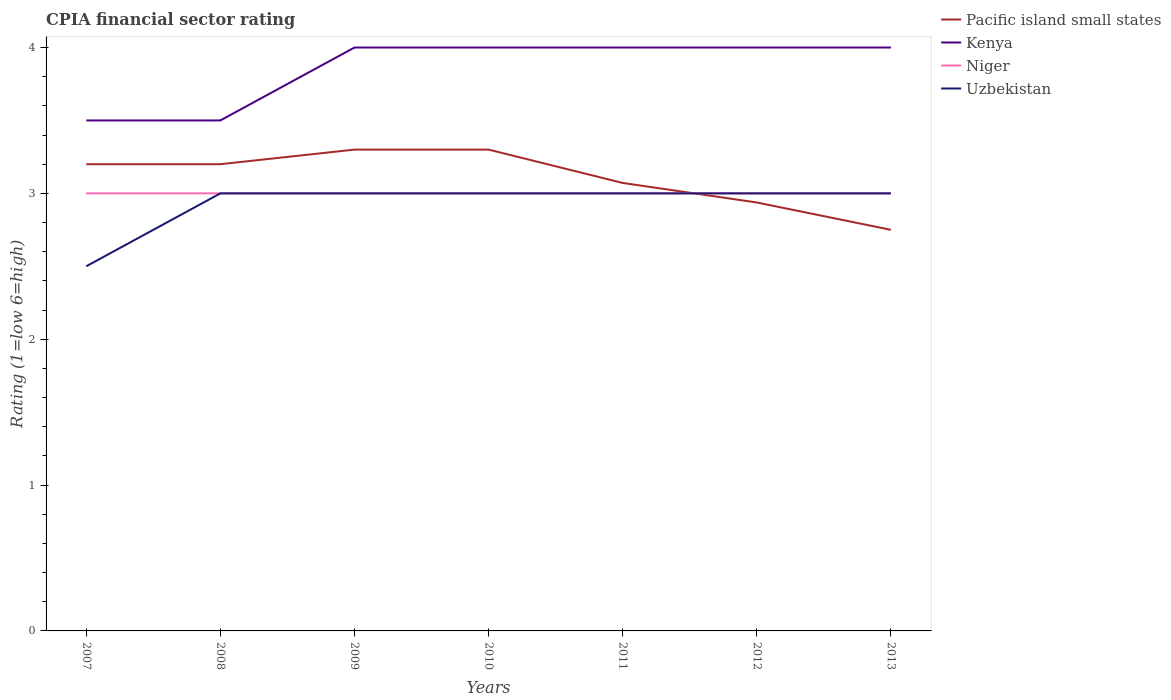How many different coloured lines are there?
Offer a very short reply. 4. Does the line corresponding to Pacific island small states intersect with the line corresponding to Uzbekistan?
Provide a short and direct response. Yes. Across all years, what is the maximum CPIA rating in Niger?
Make the answer very short. 3. What is the total CPIA rating in Pacific island small states in the graph?
Offer a terse response. 0.36. What is the difference between the highest and the lowest CPIA rating in Uzbekistan?
Provide a succinct answer. 6. Does the graph contain grids?
Your answer should be very brief. No. What is the title of the graph?
Keep it short and to the point. CPIA financial sector rating. Does "Argentina" appear as one of the legend labels in the graph?
Your answer should be very brief. No. What is the label or title of the Y-axis?
Your response must be concise. Rating (1=low 6=high). What is the Rating (1=low 6=high) of Kenya in 2007?
Your response must be concise. 3.5. What is the Rating (1=low 6=high) in Uzbekistan in 2007?
Provide a short and direct response. 2.5. What is the Rating (1=low 6=high) in Pacific island small states in 2008?
Ensure brevity in your answer.  3.2. What is the Rating (1=low 6=high) in Uzbekistan in 2008?
Offer a terse response. 3. What is the Rating (1=low 6=high) in Niger in 2009?
Give a very brief answer. 3. What is the Rating (1=low 6=high) in Uzbekistan in 2009?
Give a very brief answer. 3. What is the Rating (1=low 6=high) of Pacific island small states in 2010?
Your answer should be very brief. 3.3. What is the Rating (1=low 6=high) in Niger in 2010?
Provide a short and direct response. 3. What is the Rating (1=low 6=high) in Uzbekistan in 2010?
Your answer should be very brief. 3. What is the Rating (1=low 6=high) in Pacific island small states in 2011?
Offer a terse response. 3.07. What is the Rating (1=low 6=high) in Niger in 2011?
Make the answer very short. 3. What is the Rating (1=low 6=high) in Pacific island small states in 2012?
Provide a short and direct response. 2.94. What is the Rating (1=low 6=high) in Kenya in 2012?
Make the answer very short. 4. What is the Rating (1=low 6=high) of Niger in 2012?
Your response must be concise. 3. What is the Rating (1=low 6=high) of Uzbekistan in 2012?
Make the answer very short. 3. What is the Rating (1=low 6=high) in Pacific island small states in 2013?
Offer a very short reply. 2.75. What is the Rating (1=low 6=high) in Niger in 2013?
Your response must be concise. 3. Across all years, what is the maximum Rating (1=low 6=high) of Pacific island small states?
Your answer should be compact. 3.3. Across all years, what is the maximum Rating (1=low 6=high) in Kenya?
Offer a very short reply. 4. Across all years, what is the maximum Rating (1=low 6=high) in Niger?
Your answer should be very brief. 3. Across all years, what is the minimum Rating (1=low 6=high) of Pacific island small states?
Give a very brief answer. 2.75. What is the total Rating (1=low 6=high) of Pacific island small states in the graph?
Give a very brief answer. 21.76. What is the difference between the Rating (1=low 6=high) of Uzbekistan in 2007 and that in 2008?
Offer a terse response. -0.5. What is the difference between the Rating (1=low 6=high) in Pacific island small states in 2007 and that in 2009?
Your response must be concise. -0.1. What is the difference between the Rating (1=low 6=high) in Uzbekistan in 2007 and that in 2009?
Keep it short and to the point. -0.5. What is the difference between the Rating (1=low 6=high) of Kenya in 2007 and that in 2010?
Offer a terse response. -0.5. What is the difference between the Rating (1=low 6=high) of Uzbekistan in 2007 and that in 2010?
Your answer should be compact. -0.5. What is the difference between the Rating (1=low 6=high) of Pacific island small states in 2007 and that in 2011?
Make the answer very short. 0.13. What is the difference between the Rating (1=low 6=high) in Pacific island small states in 2007 and that in 2012?
Give a very brief answer. 0.26. What is the difference between the Rating (1=low 6=high) in Niger in 2007 and that in 2012?
Your answer should be very brief. 0. What is the difference between the Rating (1=low 6=high) in Uzbekistan in 2007 and that in 2012?
Make the answer very short. -0.5. What is the difference between the Rating (1=low 6=high) of Pacific island small states in 2007 and that in 2013?
Provide a short and direct response. 0.45. What is the difference between the Rating (1=low 6=high) in Niger in 2007 and that in 2013?
Your answer should be very brief. 0. What is the difference between the Rating (1=low 6=high) of Uzbekistan in 2007 and that in 2013?
Provide a succinct answer. -0.5. What is the difference between the Rating (1=low 6=high) of Pacific island small states in 2008 and that in 2009?
Your response must be concise. -0.1. What is the difference between the Rating (1=low 6=high) in Kenya in 2008 and that in 2009?
Ensure brevity in your answer.  -0.5. What is the difference between the Rating (1=low 6=high) in Pacific island small states in 2008 and that in 2010?
Provide a short and direct response. -0.1. What is the difference between the Rating (1=low 6=high) of Kenya in 2008 and that in 2010?
Make the answer very short. -0.5. What is the difference between the Rating (1=low 6=high) of Niger in 2008 and that in 2010?
Provide a succinct answer. 0. What is the difference between the Rating (1=low 6=high) in Uzbekistan in 2008 and that in 2010?
Your answer should be compact. 0. What is the difference between the Rating (1=low 6=high) of Pacific island small states in 2008 and that in 2011?
Give a very brief answer. 0.13. What is the difference between the Rating (1=low 6=high) in Kenya in 2008 and that in 2011?
Provide a succinct answer. -0.5. What is the difference between the Rating (1=low 6=high) in Uzbekistan in 2008 and that in 2011?
Your answer should be very brief. 0. What is the difference between the Rating (1=low 6=high) of Pacific island small states in 2008 and that in 2012?
Give a very brief answer. 0.26. What is the difference between the Rating (1=low 6=high) in Kenya in 2008 and that in 2012?
Offer a very short reply. -0.5. What is the difference between the Rating (1=low 6=high) in Pacific island small states in 2008 and that in 2013?
Give a very brief answer. 0.45. What is the difference between the Rating (1=low 6=high) of Niger in 2008 and that in 2013?
Your answer should be very brief. 0. What is the difference between the Rating (1=low 6=high) in Kenya in 2009 and that in 2010?
Your response must be concise. 0. What is the difference between the Rating (1=low 6=high) in Uzbekistan in 2009 and that in 2010?
Make the answer very short. 0. What is the difference between the Rating (1=low 6=high) in Pacific island small states in 2009 and that in 2011?
Your answer should be very brief. 0.23. What is the difference between the Rating (1=low 6=high) of Kenya in 2009 and that in 2011?
Keep it short and to the point. 0. What is the difference between the Rating (1=low 6=high) in Pacific island small states in 2009 and that in 2012?
Offer a terse response. 0.36. What is the difference between the Rating (1=low 6=high) in Pacific island small states in 2009 and that in 2013?
Offer a terse response. 0.55. What is the difference between the Rating (1=low 6=high) of Kenya in 2009 and that in 2013?
Your answer should be very brief. 0. What is the difference between the Rating (1=low 6=high) of Uzbekistan in 2009 and that in 2013?
Your answer should be very brief. 0. What is the difference between the Rating (1=low 6=high) of Pacific island small states in 2010 and that in 2011?
Provide a succinct answer. 0.23. What is the difference between the Rating (1=low 6=high) of Kenya in 2010 and that in 2011?
Make the answer very short. 0. What is the difference between the Rating (1=low 6=high) of Uzbekistan in 2010 and that in 2011?
Your response must be concise. 0. What is the difference between the Rating (1=low 6=high) of Pacific island small states in 2010 and that in 2012?
Offer a very short reply. 0.36. What is the difference between the Rating (1=low 6=high) in Niger in 2010 and that in 2012?
Provide a short and direct response. 0. What is the difference between the Rating (1=low 6=high) in Uzbekistan in 2010 and that in 2012?
Offer a terse response. 0. What is the difference between the Rating (1=low 6=high) in Pacific island small states in 2010 and that in 2013?
Ensure brevity in your answer.  0.55. What is the difference between the Rating (1=low 6=high) of Kenya in 2010 and that in 2013?
Offer a terse response. 0. What is the difference between the Rating (1=low 6=high) in Niger in 2010 and that in 2013?
Your answer should be very brief. 0. What is the difference between the Rating (1=low 6=high) in Uzbekistan in 2010 and that in 2013?
Your answer should be compact. 0. What is the difference between the Rating (1=low 6=high) in Pacific island small states in 2011 and that in 2012?
Make the answer very short. 0.13. What is the difference between the Rating (1=low 6=high) in Kenya in 2011 and that in 2012?
Give a very brief answer. 0. What is the difference between the Rating (1=low 6=high) of Pacific island small states in 2011 and that in 2013?
Ensure brevity in your answer.  0.32. What is the difference between the Rating (1=low 6=high) of Kenya in 2011 and that in 2013?
Provide a succinct answer. 0. What is the difference between the Rating (1=low 6=high) of Pacific island small states in 2012 and that in 2013?
Offer a terse response. 0.19. What is the difference between the Rating (1=low 6=high) in Niger in 2012 and that in 2013?
Offer a very short reply. 0. What is the difference between the Rating (1=low 6=high) in Pacific island small states in 2007 and the Rating (1=low 6=high) in Kenya in 2008?
Your answer should be compact. -0.3. What is the difference between the Rating (1=low 6=high) of Pacific island small states in 2007 and the Rating (1=low 6=high) of Uzbekistan in 2008?
Provide a short and direct response. 0.2. What is the difference between the Rating (1=low 6=high) of Kenya in 2007 and the Rating (1=low 6=high) of Niger in 2008?
Give a very brief answer. 0.5. What is the difference between the Rating (1=low 6=high) in Kenya in 2007 and the Rating (1=low 6=high) in Niger in 2009?
Offer a very short reply. 0.5. What is the difference between the Rating (1=low 6=high) in Niger in 2007 and the Rating (1=low 6=high) in Uzbekistan in 2009?
Ensure brevity in your answer.  0. What is the difference between the Rating (1=low 6=high) of Pacific island small states in 2007 and the Rating (1=low 6=high) of Kenya in 2010?
Keep it short and to the point. -0.8. What is the difference between the Rating (1=low 6=high) in Pacific island small states in 2007 and the Rating (1=low 6=high) in Uzbekistan in 2010?
Ensure brevity in your answer.  0.2. What is the difference between the Rating (1=low 6=high) in Kenya in 2007 and the Rating (1=low 6=high) in Niger in 2010?
Offer a very short reply. 0.5. What is the difference between the Rating (1=low 6=high) of Kenya in 2007 and the Rating (1=low 6=high) of Uzbekistan in 2010?
Provide a short and direct response. 0.5. What is the difference between the Rating (1=low 6=high) in Pacific island small states in 2007 and the Rating (1=low 6=high) in Kenya in 2011?
Offer a very short reply. -0.8. What is the difference between the Rating (1=low 6=high) in Pacific island small states in 2007 and the Rating (1=low 6=high) in Niger in 2011?
Offer a very short reply. 0.2. What is the difference between the Rating (1=low 6=high) in Pacific island small states in 2007 and the Rating (1=low 6=high) in Uzbekistan in 2011?
Offer a very short reply. 0.2. What is the difference between the Rating (1=low 6=high) of Kenya in 2007 and the Rating (1=low 6=high) of Uzbekistan in 2011?
Ensure brevity in your answer.  0.5. What is the difference between the Rating (1=low 6=high) of Niger in 2007 and the Rating (1=low 6=high) of Uzbekistan in 2011?
Provide a short and direct response. 0. What is the difference between the Rating (1=low 6=high) of Pacific island small states in 2007 and the Rating (1=low 6=high) of Kenya in 2012?
Ensure brevity in your answer.  -0.8. What is the difference between the Rating (1=low 6=high) of Pacific island small states in 2007 and the Rating (1=low 6=high) of Uzbekistan in 2012?
Keep it short and to the point. 0.2. What is the difference between the Rating (1=low 6=high) in Kenya in 2007 and the Rating (1=low 6=high) in Uzbekistan in 2012?
Ensure brevity in your answer.  0.5. What is the difference between the Rating (1=low 6=high) of Niger in 2007 and the Rating (1=low 6=high) of Uzbekistan in 2012?
Provide a succinct answer. 0. What is the difference between the Rating (1=low 6=high) in Pacific island small states in 2007 and the Rating (1=low 6=high) in Kenya in 2013?
Ensure brevity in your answer.  -0.8. What is the difference between the Rating (1=low 6=high) in Pacific island small states in 2007 and the Rating (1=low 6=high) in Niger in 2013?
Offer a very short reply. 0.2. What is the difference between the Rating (1=low 6=high) of Kenya in 2007 and the Rating (1=low 6=high) of Niger in 2013?
Provide a short and direct response. 0.5. What is the difference between the Rating (1=low 6=high) in Niger in 2007 and the Rating (1=low 6=high) in Uzbekistan in 2013?
Make the answer very short. 0. What is the difference between the Rating (1=low 6=high) in Pacific island small states in 2008 and the Rating (1=low 6=high) in Kenya in 2009?
Offer a terse response. -0.8. What is the difference between the Rating (1=low 6=high) in Pacific island small states in 2008 and the Rating (1=low 6=high) in Niger in 2009?
Your answer should be very brief. 0.2. What is the difference between the Rating (1=low 6=high) of Pacific island small states in 2008 and the Rating (1=low 6=high) of Uzbekistan in 2009?
Provide a short and direct response. 0.2. What is the difference between the Rating (1=low 6=high) of Niger in 2008 and the Rating (1=low 6=high) of Uzbekistan in 2009?
Your answer should be very brief. 0. What is the difference between the Rating (1=low 6=high) in Pacific island small states in 2008 and the Rating (1=low 6=high) in Kenya in 2010?
Give a very brief answer. -0.8. What is the difference between the Rating (1=low 6=high) of Pacific island small states in 2008 and the Rating (1=low 6=high) of Niger in 2010?
Give a very brief answer. 0.2. What is the difference between the Rating (1=low 6=high) in Kenya in 2008 and the Rating (1=low 6=high) in Niger in 2010?
Provide a succinct answer. 0.5. What is the difference between the Rating (1=low 6=high) of Kenya in 2008 and the Rating (1=low 6=high) of Uzbekistan in 2010?
Your answer should be very brief. 0.5. What is the difference between the Rating (1=low 6=high) of Pacific island small states in 2008 and the Rating (1=low 6=high) of Niger in 2011?
Provide a succinct answer. 0.2. What is the difference between the Rating (1=low 6=high) in Kenya in 2008 and the Rating (1=low 6=high) in Niger in 2011?
Provide a short and direct response. 0.5. What is the difference between the Rating (1=low 6=high) in Niger in 2008 and the Rating (1=low 6=high) in Uzbekistan in 2011?
Offer a very short reply. 0. What is the difference between the Rating (1=low 6=high) in Pacific island small states in 2008 and the Rating (1=low 6=high) in Niger in 2012?
Your answer should be compact. 0.2. What is the difference between the Rating (1=low 6=high) in Pacific island small states in 2008 and the Rating (1=low 6=high) in Uzbekistan in 2012?
Offer a terse response. 0.2. What is the difference between the Rating (1=low 6=high) in Kenya in 2008 and the Rating (1=low 6=high) in Niger in 2012?
Keep it short and to the point. 0.5. What is the difference between the Rating (1=low 6=high) of Niger in 2008 and the Rating (1=low 6=high) of Uzbekistan in 2012?
Provide a succinct answer. 0. What is the difference between the Rating (1=low 6=high) of Pacific island small states in 2008 and the Rating (1=low 6=high) of Niger in 2013?
Ensure brevity in your answer.  0.2. What is the difference between the Rating (1=low 6=high) of Pacific island small states in 2008 and the Rating (1=low 6=high) of Uzbekistan in 2013?
Ensure brevity in your answer.  0.2. What is the difference between the Rating (1=low 6=high) in Kenya in 2008 and the Rating (1=low 6=high) in Niger in 2013?
Your answer should be very brief. 0.5. What is the difference between the Rating (1=low 6=high) in Kenya in 2008 and the Rating (1=low 6=high) in Uzbekistan in 2013?
Offer a very short reply. 0.5. What is the difference between the Rating (1=low 6=high) in Niger in 2008 and the Rating (1=low 6=high) in Uzbekistan in 2013?
Provide a short and direct response. 0. What is the difference between the Rating (1=low 6=high) of Pacific island small states in 2009 and the Rating (1=low 6=high) of Kenya in 2010?
Make the answer very short. -0.7. What is the difference between the Rating (1=low 6=high) in Pacific island small states in 2009 and the Rating (1=low 6=high) in Niger in 2010?
Provide a short and direct response. 0.3. What is the difference between the Rating (1=low 6=high) in Kenya in 2009 and the Rating (1=low 6=high) in Niger in 2010?
Give a very brief answer. 1. What is the difference between the Rating (1=low 6=high) in Niger in 2009 and the Rating (1=low 6=high) in Uzbekistan in 2010?
Offer a terse response. 0. What is the difference between the Rating (1=low 6=high) in Pacific island small states in 2009 and the Rating (1=low 6=high) in Kenya in 2011?
Your answer should be compact. -0.7. What is the difference between the Rating (1=low 6=high) in Pacific island small states in 2009 and the Rating (1=low 6=high) in Niger in 2011?
Ensure brevity in your answer.  0.3. What is the difference between the Rating (1=low 6=high) of Pacific island small states in 2009 and the Rating (1=low 6=high) of Uzbekistan in 2011?
Your response must be concise. 0.3. What is the difference between the Rating (1=low 6=high) of Kenya in 2009 and the Rating (1=low 6=high) of Niger in 2011?
Your answer should be compact. 1. What is the difference between the Rating (1=low 6=high) of Kenya in 2009 and the Rating (1=low 6=high) of Uzbekistan in 2011?
Your answer should be very brief. 1. What is the difference between the Rating (1=low 6=high) in Niger in 2009 and the Rating (1=low 6=high) in Uzbekistan in 2011?
Your answer should be compact. 0. What is the difference between the Rating (1=low 6=high) of Pacific island small states in 2009 and the Rating (1=low 6=high) of Kenya in 2012?
Your answer should be compact. -0.7. What is the difference between the Rating (1=low 6=high) in Pacific island small states in 2009 and the Rating (1=low 6=high) in Niger in 2012?
Provide a succinct answer. 0.3. What is the difference between the Rating (1=low 6=high) in Kenya in 2009 and the Rating (1=low 6=high) in Niger in 2012?
Provide a succinct answer. 1. What is the difference between the Rating (1=low 6=high) of Pacific island small states in 2009 and the Rating (1=low 6=high) of Kenya in 2013?
Offer a very short reply. -0.7. What is the difference between the Rating (1=low 6=high) in Pacific island small states in 2009 and the Rating (1=low 6=high) in Niger in 2013?
Ensure brevity in your answer.  0.3. What is the difference between the Rating (1=low 6=high) of Niger in 2009 and the Rating (1=low 6=high) of Uzbekistan in 2013?
Your answer should be compact. 0. What is the difference between the Rating (1=low 6=high) of Kenya in 2010 and the Rating (1=low 6=high) of Uzbekistan in 2011?
Your answer should be compact. 1. What is the difference between the Rating (1=low 6=high) of Niger in 2010 and the Rating (1=low 6=high) of Uzbekistan in 2011?
Your answer should be very brief. 0. What is the difference between the Rating (1=low 6=high) in Pacific island small states in 2010 and the Rating (1=low 6=high) in Niger in 2012?
Your answer should be compact. 0.3. What is the difference between the Rating (1=low 6=high) of Pacific island small states in 2010 and the Rating (1=low 6=high) of Uzbekistan in 2012?
Provide a short and direct response. 0.3. What is the difference between the Rating (1=low 6=high) of Kenya in 2010 and the Rating (1=low 6=high) of Uzbekistan in 2012?
Make the answer very short. 1. What is the difference between the Rating (1=low 6=high) of Pacific island small states in 2010 and the Rating (1=low 6=high) of Kenya in 2013?
Give a very brief answer. -0.7. What is the difference between the Rating (1=low 6=high) of Pacific island small states in 2010 and the Rating (1=low 6=high) of Uzbekistan in 2013?
Your answer should be very brief. 0.3. What is the difference between the Rating (1=low 6=high) of Pacific island small states in 2011 and the Rating (1=low 6=high) of Kenya in 2012?
Make the answer very short. -0.93. What is the difference between the Rating (1=low 6=high) of Pacific island small states in 2011 and the Rating (1=low 6=high) of Niger in 2012?
Keep it short and to the point. 0.07. What is the difference between the Rating (1=low 6=high) of Pacific island small states in 2011 and the Rating (1=low 6=high) of Uzbekistan in 2012?
Ensure brevity in your answer.  0.07. What is the difference between the Rating (1=low 6=high) in Pacific island small states in 2011 and the Rating (1=low 6=high) in Kenya in 2013?
Make the answer very short. -0.93. What is the difference between the Rating (1=low 6=high) of Pacific island small states in 2011 and the Rating (1=low 6=high) of Niger in 2013?
Provide a short and direct response. 0.07. What is the difference between the Rating (1=low 6=high) of Pacific island small states in 2011 and the Rating (1=low 6=high) of Uzbekistan in 2013?
Keep it short and to the point. 0.07. What is the difference between the Rating (1=low 6=high) of Kenya in 2011 and the Rating (1=low 6=high) of Uzbekistan in 2013?
Ensure brevity in your answer.  1. What is the difference between the Rating (1=low 6=high) of Niger in 2011 and the Rating (1=low 6=high) of Uzbekistan in 2013?
Provide a short and direct response. 0. What is the difference between the Rating (1=low 6=high) of Pacific island small states in 2012 and the Rating (1=low 6=high) of Kenya in 2013?
Offer a terse response. -1.06. What is the difference between the Rating (1=low 6=high) of Pacific island small states in 2012 and the Rating (1=low 6=high) of Niger in 2013?
Make the answer very short. -0.06. What is the difference between the Rating (1=low 6=high) in Pacific island small states in 2012 and the Rating (1=low 6=high) in Uzbekistan in 2013?
Provide a short and direct response. -0.06. What is the difference between the Rating (1=low 6=high) in Niger in 2012 and the Rating (1=low 6=high) in Uzbekistan in 2013?
Provide a short and direct response. 0. What is the average Rating (1=low 6=high) in Pacific island small states per year?
Your response must be concise. 3.11. What is the average Rating (1=low 6=high) in Kenya per year?
Keep it short and to the point. 3.86. What is the average Rating (1=low 6=high) of Niger per year?
Give a very brief answer. 3. What is the average Rating (1=low 6=high) of Uzbekistan per year?
Offer a very short reply. 2.93. In the year 2007, what is the difference between the Rating (1=low 6=high) in Pacific island small states and Rating (1=low 6=high) in Kenya?
Keep it short and to the point. -0.3. In the year 2007, what is the difference between the Rating (1=low 6=high) of Pacific island small states and Rating (1=low 6=high) of Niger?
Ensure brevity in your answer.  0.2. In the year 2007, what is the difference between the Rating (1=low 6=high) of Pacific island small states and Rating (1=low 6=high) of Uzbekistan?
Make the answer very short. 0.7. In the year 2007, what is the difference between the Rating (1=low 6=high) in Kenya and Rating (1=low 6=high) in Niger?
Provide a succinct answer. 0.5. In the year 2007, what is the difference between the Rating (1=low 6=high) of Kenya and Rating (1=low 6=high) of Uzbekistan?
Make the answer very short. 1. In the year 2007, what is the difference between the Rating (1=low 6=high) of Niger and Rating (1=low 6=high) of Uzbekistan?
Your answer should be very brief. 0.5. In the year 2008, what is the difference between the Rating (1=low 6=high) of Pacific island small states and Rating (1=low 6=high) of Kenya?
Your answer should be compact. -0.3. In the year 2008, what is the difference between the Rating (1=low 6=high) in Pacific island small states and Rating (1=low 6=high) in Niger?
Ensure brevity in your answer.  0.2. In the year 2008, what is the difference between the Rating (1=low 6=high) of Pacific island small states and Rating (1=low 6=high) of Uzbekistan?
Your answer should be very brief. 0.2. In the year 2008, what is the difference between the Rating (1=low 6=high) in Kenya and Rating (1=low 6=high) in Niger?
Provide a short and direct response. 0.5. In the year 2008, what is the difference between the Rating (1=low 6=high) in Kenya and Rating (1=low 6=high) in Uzbekistan?
Offer a terse response. 0.5. In the year 2008, what is the difference between the Rating (1=low 6=high) of Niger and Rating (1=low 6=high) of Uzbekistan?
Provide a succinct answer. 0. In the year 2009, what is the difference between the Rating (1=low 6=high) of Pacific island small states and Rating (1=low 6=high) of Niger?
Provide a succinct answer. 0.3. In the year 2009, what is the difference between the Rating (1=low 6=high) of Kenya and Rating (1=low 6=high) of Niger?
Your answer should be very brief. 1. In the year 2010, what is the difference between the Rating (1=low 6=high) of Pacific island small states and Rating (1=low 6=high) of Niger?
Provide a succinct answer. 0.3. In the year 2010, what is the difference between the Rating (1=low 6=high) of Pacific island small states and Rating (1=low 6=high) of Uzbekistan?
Give a very brief answer. 0.3. In the year 2010, what is the difference between the Rating (1=low 6=high) in Kenya and Rating (1=low 6=high) in Niger?
Your answer should be very brief. 1. In the year 2010, what is the difference between the Rating (1=low 6=high) of Kenya and Rating (1=low 6=high) of Uzbekistan?
Provide a short and direct response. 1. In the year 2010, what is the difference between the Rating (1=low 6=high) in Niger and Rating (1=low 6=high) in Uzbekistan?
Provide a succinct answer. 0. In the year 2011, what is the difference between the Rating (1=low 6=high) of Pacific island small states and Rating (1=low 6=high) of Kenya?
Your answer should be compact. -0.93. In the year 2011, what is the difference between the Rating (1=low 6=high) of Pacific island small states and Rating (1=low 6=high) of Niger?
Your answer should be very brief. 0.07. In the year 2011, what is the difference between the Rating (1=low 6=high) of Pacific island small states and Rating (1=low 6=high) of Uzbekistan?
Your answer should be compact. 0.07. In the year 2011, what is the difference between the Rating (1=low 6=high) in Kenya and Rating (1=low 6=high) in Uzbekistan?
Your answer should be compact. 1. In the year 2012, what is the difference between the Rating (1=low 6=high) in Pacific island small states and Rating (1=low 6=high) in Kenya?
Your answer should be very brief. -1.06. In the year 2012, what is the difference between the Rating (1=low 6=high) in Pacific island small states and Rating (1=low 6=high) in Niger?
Keep it short and to the point. -0.06. In the year 2012, what is the difference between the Rating (1=low 6=high) of Pacific island small states and Rating (1=low 6=high) of Uzbekistan?
Offer a terse response. -0.06. In the year 2012, what is the difference between the Rating (1=low 6=high) of Kenya and Rating (1=low 6=high) of Niger?
Make the answer very short. 1. In the year 2012, what is the difference between the Rating (1=low 6=high) of Niger and Rating (1=low 6=high) of Uzbekistan?
Give a very brief answer. 0. In the year 2013, what is the difference between the Rating (1=low 6=high) of Pacific island small states and Rating (1=low 6=high) of Kenya?
Offer a very short reply. -1.25. In the year 2013, what is the difference between the Rating (1=low 6=high) of Pacific island small states and Rating (1=low 6=high) of Uzbekistan?
Ensure brevity in your answer.  -0.25. In the year 2013, what is the difference between the Rating (1=low 6=high) in Kenya and Rating (1=low 6=high) in Niger?
Your answer should be compact. 1. What is the ratio of the Rating (1=low 6=high) of Kenya in 2007 to that in 2008?
Offer a terse response. 1. What is the ratio of the Rating (1=low 6=high) of Niger in 2007 to that in 2008?
Keep it short and to the point. 1. What is the ratio of the Rating (1=low 6=high) in Uzbekistan in 2007 to that in 2008?
Your response must be concise. 0.83. What is the ratio of the Rating (1=low 6=high) of Pacific island small states in 2007 to that in 2009?
Your response must be concise. 0.97. What is the ratio of the Rating (1=low 6=high) in Kenya in 2007 to that in 2009?
Give a very brief answer. 0.88. What is the ratio of the Rating (1=low 6=high) in Niger in 2007 to that in 2009?
Your response must be concise. 1. What is the ratio of the Rating (1=low 6=high) of Uzbekistan in 2007 to that in 2009?
Keep it short and to the point. 0.83. What is the ratio of the Rating (1=low 6=high) in Pacific island small states in 2007 to that in 2010?
Ensure brevity in your answer.  0.97. What is the ratio of the Rating (1=low 6=high) of Kenya in 2007 to that in 2010?
Your answer should be very brief. 0.88. What is the ratio of the Rating (1=low 6=high) of Pacific island small states in 2007 to that in 2011?
Your answer should be compact. 1.04. What is the ratio of the Rating (1=low 6=high) of Kenya in 2007 to that in 2011?
Your response must be concise. 0.88. What is the ratio of the Rating (1=low 6=high) in Niger in 2007 to that in 2011?
Your answer should be compact. 1. What is the ratio of the Rating (1=low 6=high) of Pacific island small states in 2007 to that in 2012?
Keep it short and to the point. 1.09. What is the ratio of the Rating (1=low 6=high) of Kenya in 2007 to that in 2012?
Keep it short and to the point. 0.88. What is the ratio of the Rating (1=low 6=high) of Uzbekistan in 2007 to that in 2012?
Offer a very short reply. 0.83. What is the ratio of the Rating (1=low 6=high) of Pacific island small states in 2007 to that in 2013?
Offer a very short reply. 1.16. What is the ratio of the Rating (1=low 6=high) in Kenya in 2007 to that in 2013?
Provide a short and direct response. 0.88. What is the ratio of the Rating (1=low 6=high) of Pacific island small states in 2008 to that in 2009?
Ensure brevity in your answer.  0.97. What is the ratio of the Rating (1=low 6=high) in Niger in 2008 to that in 2009?
Give a very brief answer. 1. What is the ratio of the Rating (1=low 6=high) in Uzbekistan in 2008 to that in 2009?
Your answer should be compact. 1. What is the ratio of the Rating (1=low 6=high) of Pacific island small states in 2008 to that in 2010?
Keep it short and to the point. 0.97. What is the ratio of the Rating (1=low 6=high) in Kenya in 2008 to that in 2010?
Your answer should be compact. 0.88. What is the ratio of the Rating (1=low 6=high) in Uzbekistan in 2008 to that in 2010?
Your answer should be very brief. 1. What is the ratio of the Rating (1=low 6=high) of Pacific island small states in 2008 to that in 2011?
Ensure brevity in your answer.  1.04. What is the ratio of the Rating (1=low 6=high) of Pacific island small states in 2008 to that in 2012?
Your response must be concise. 1.09. What is the ratio of the Rating (1=low 6=high) of Niger in 2008 to that in 2012?
Provide a succinct answer. 1. What is the ratio of the Rating (1=low 6=high) of Pacific island small states in 2008 to that in 2013?
Ensure brevity in your answer.  1.16. What is the ratio of the Rating (1=low 6=high) in Kenya in 2008 to that in 2013?
Offer a terse response. 0.88. What is the ratio of the Rating (1=low 6=high) of Kenya in 2009 to that in 2010?
Give a very brief answer. 1. What is the ratio of the Rating (1=low 6=high) in Niger in 2009 to that in 2010?
Your answer should be compact. 1. What is the ratio of the Rating (1=low 6=high) of Pacific island small states in 2009 to that in 2011?
Your answer should be compact. 1.07. What is the ratio of the Rating (1=low 6=high) in Kenya in 2009 to that in 2011?
Offer a terse response. 1. What is the ratio of the Rating (1=low 6=high) in Niger in 2009 to that in 2011?
Provide a short and direct response. 1. What is the ratio of the Rating (1=low 6=high) in Uzbekistan in 2009 to that in 2011?
Give a very brief answer. 1. What is the ratio of the Rating (1=low 6=high) of Pacific island small states in 2009 to that in 2012?
Keep it short and to the point. 1.12. What is the ratio of the Rating (1=low 6=high) of Uzbekistan in 2009 to that in 2012?
Your response must be concise. 1. What is the ratio of the Rating (1=low 6=high) of Kenya in 2009 to that in 2013?
Provide a succinct answer. 1. What is the ratio of the Rating (1=low 6=high) in Niger in 2009 to that in 2013?
Provide a short and direct response. 1. What is the ratio of the Rating (1=low 6=high) in Uzbekistan in 2009 to that in 2013?
Offer a very short reply. 1. What is the ratio of the Rating (1=low 6=high) in Pacific island small states in 2010 to that in 2011?
Keep it short and to the point. 1.07. What is the ratio of the Rating (1=low 6=high) of Uzbekistan in 2010 to that in 2011?
Your response must be concise. 1. What is the ratio of the Rating (1=low 6=high) of Pacific island small states in 2010 to that in 2012?
Ensure brevity in your answer.  1.12. What is the ratio of the Rating (1=low 6=high) of Niger in 2010 to that in 2012?
Give a very brief answer. 1. What is the ratio of the Rating (1=low 6=high) of Pacific island small states in 2010 to that in 2013?
Make the answer very short. 1.2. What is the ratio of the Rating (1=low 6=high) in Kenya in 2010 to that in 2013?
Make the answer very short. 1. What is the ratio of the Rating (1=low 6=high) in Niger in 2010 to that in 2013?
Keep it short and to the point. 1. What is the ratio of the Rating (1=low 6=high) in Pacific island small states in 2011 to that in 2012?
Offer a very short reply. 1.05. What is the ratio of the Rating (1=low 6=high) in Kenya in 2011 to that in 2012?
Make the answer very short. 1. What is the ratio of the Rating (1=low 6=high) of Pacific island small states in 2011 to that in 2013?
Offer a terse response. 1.12. What is the ratio of the Rating (1=low 6=high) of Niger in 2011 to that in 2013?
Make the answer very short. 1. What is the ratio of the Rating (1=low 6=high) in Pacific island small states in 2012 to that in 2013?
Your answer should be compact. 1.07. What is the ratio of the Rating (1=low 6=high) in Kenya in 2012 to that in 2013?
Ensure brevity in your answer.  1. What is the ratio of the Rating (1=low 6=high) of Uzbekistan in 2012 to that in 2013?
Provide a succinct answer. 1. What is the difference between the highest and the second highest Rating (1=low 6=high) in Pacific island small states?
Make the answer very short. 0. What is the difference between the highest and the second highest Rating (1=low 6=high) of Kenya?
Ensure brevity in your answer.  0. What is the difference between the highest and the second highest Rating (1=low 6=high) in Niger?
Your answer should be compact. 0. What is the difference between the highest and the lowest Rating (1=low 6=high) of Pacific island small states?
Offer a terse response. 0.55. What is the difference between the highest and the lowest Rating (1=low 6=high) of Kenya?
Give a very brief answer. 0.5. What is the difference between the highest and the lowest Rating (1=low 6=high) of Niger?
Offer a very short reply. 0. What is the difference between the highest and the lowest Rating (1=low 6=high) of Uzbekistan?
Ensure brevity in your answer.  0.5. 